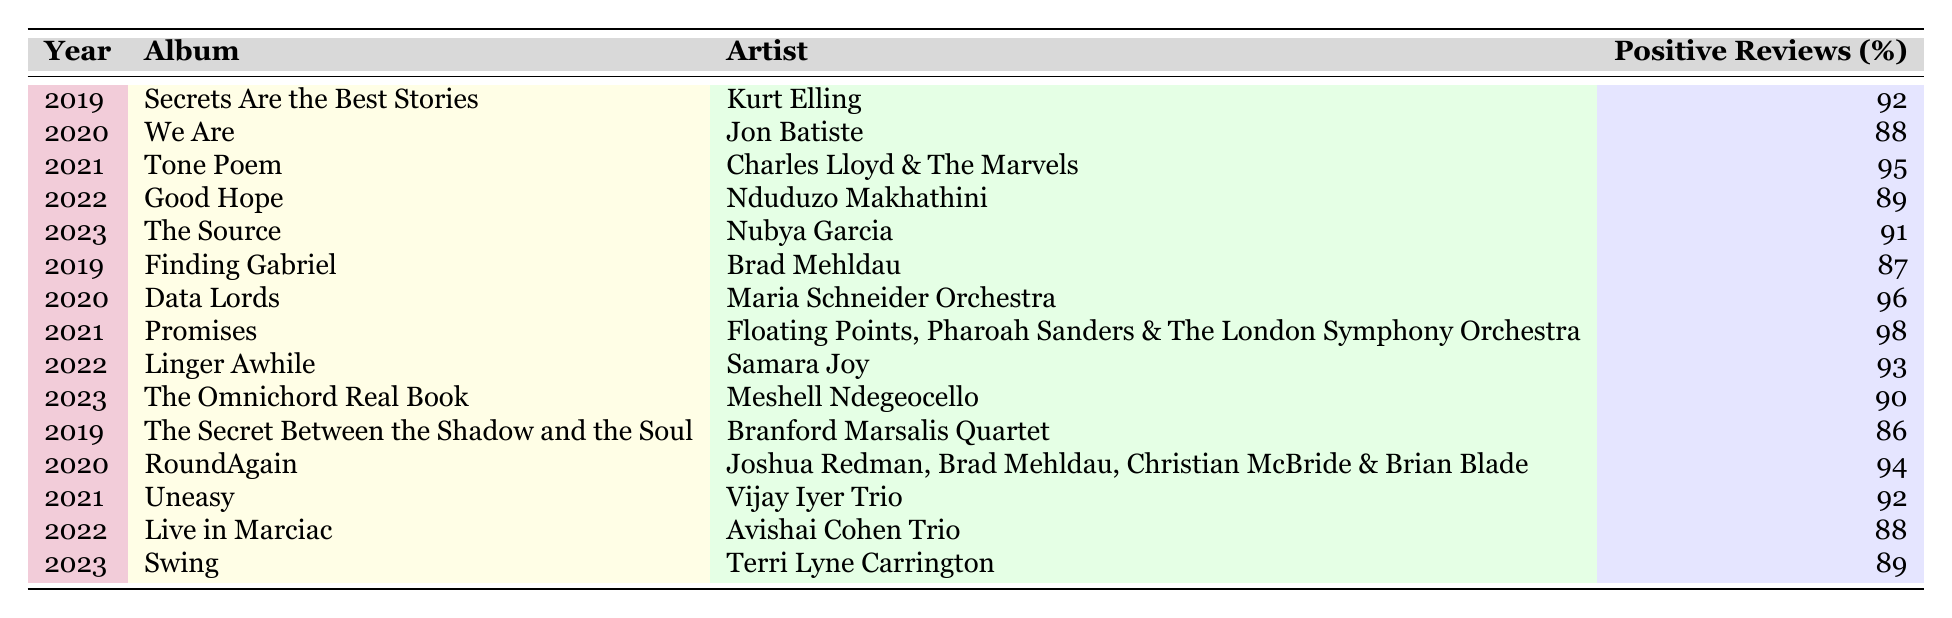What is the highest positive reviews percentage in the table? To find the highest percentage, I will scan the "Positive Reviews (%)" column for the largest value. The highest value is 98%.
Answer: 98% Which artist has an album with the lowest positive reviews percentage? By reviewing the table, I see that the lowest percentage in the "Positive Reviews (%)" column is 86%, associated with the artist Branford Marsalis Quartet and the album "The Secret Between the Shadow and the Soul".
Answer: Branford Marsalis Quartet What is the average positive reviews percentage for the year 2020? The albums for 2020 have the following percentages: 88, 96, and 94. I will calculate the average: (88 + 96 + 94) / 3 = 278 / 3 = 92.67%.
Answer: 92.67% Did any album receive more than 90% positive reviews in 2021? In 2021, the albums had the following percentages: 95, 98, and 92. Since 98% is greater than 90%, the answer is yes.
Answer: Yes Which year had the highest total positive reviews percentage across all albums? I will sum the percentages for each year: 2019 (92 + 87 + 86) = 265; 2020 (88 + 96 + 94) = 278; 2021 (95 + 98 + 92) = 285; 2022 (89 + 93 + 88) = 270; 2023 (91 + 90 + 89) = 270. The highest total is for 2021 with 285.
Answer: 2021 What is the percentage difference between the highest and lowest album positive reviews in the table? The highest percentage is 98% and the lowest is 86%. The difference is 98 - 86 = 12%.
Answer: 12% Which album from 2022 has the highest positive reviews percentage? In 2022, the albums have percentages of 89 and 93. The album "Linger Awhile" by Samara Joy received the highest positive review percentage of 93%.
Answer: Linger Awhile How many albums from the table have a positive reviews percentage of 90% or higher? I will count the albums with percentages of 90% or more: 92, 88, 95, 96, 98, 93, 91, and 90 from various years. This gives a total of 8 albums.
Answer: 8 